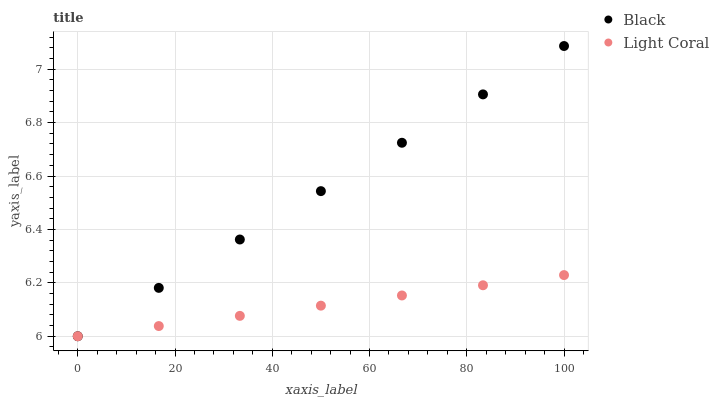Does Light Coral have the minimum area under the curve?
Answer yes or no. Yes. Does Black have the maximum area under the curve?
Answer yes or no. Yes. Does Black have the minimum area under the curve?
Answer yes or no. No. Is Light Coral the smoothest?
Answer yes or no. Yes. Is Black the roughest?
Answer yes or no. Yes. Is Black the smoothest?
Answer yes or no. No. Does Light Coral have the lowest value?
Answer yes or no. Yes. Does Black have the highest value?
Answer yes or no. Yes. Does Light Coral intersect Black?
Answer yes or no. Yes. Is Light Coral less than Black?
Answer yes or no. No. Is Light Coral greater than Black?
Answer yes or no. No. 